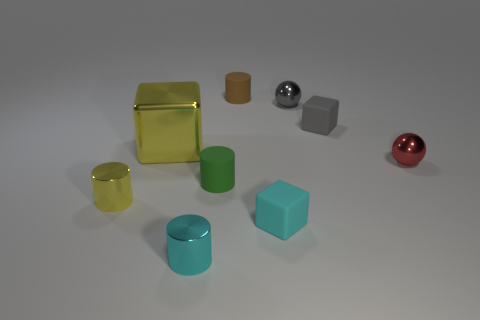What size is the block that is the same material as the gray sphere?
Your response must be concise. Large. Is the size of the red metallic sphere the same as the matte block on the right side of the gray metallic object?
Ensure brevity in your answer.  Yes. There is a cube behind the big object; what material is it?
Keep it short and to the point. Rubber. There is a rubber thing to the left of the small brown matte thing; what number of big metallic cubes are in front of it?
Offer a very short reply. 0. Is there a big object of the same shape as the small gray metallic object?
Ensure brevity in your answer.  No. There is a object that is on the left side of the large yellow shiny object; does it have the same size as the brown matte cylinder that is to the right of the big yellow shiny thing?
Give a very brief answer. Yes. There is a small cyan object that is to the left of the rubber object behind the tiny gray shiny object; what is its shape?
Offer a terse response. Cylinder. How many balls are the same size as the cyan metal cylinder?
Keep it short and to the point. 2. Are any yellow objects visible?
Offer a very short reply. Yes. There is another yellow object that is the same material as the large thing; what is its shape?
Offer a very short reply. Cylinder. 